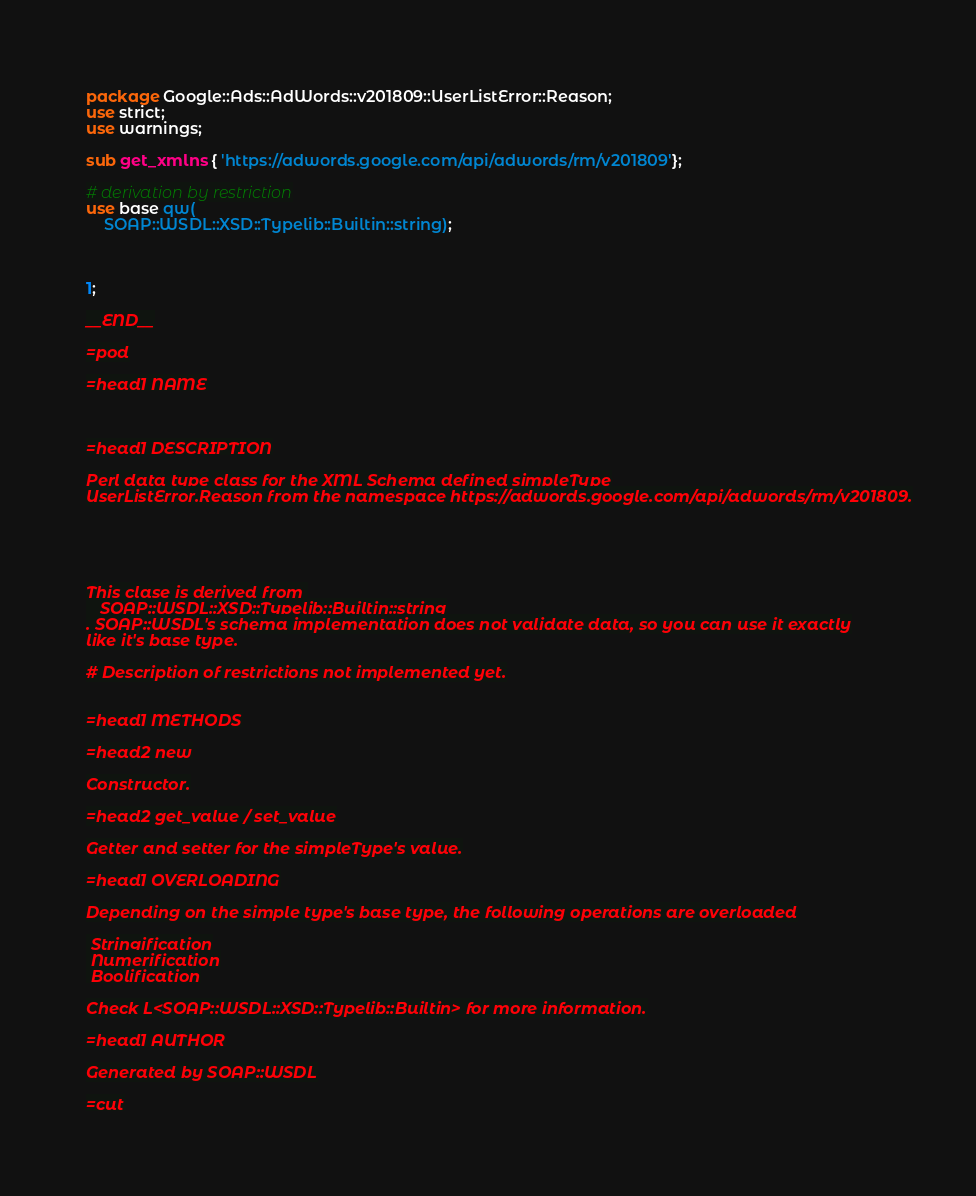Convert code to text. <code><loc_0><loc_0><loc_500><loc_500><_Perl_>package Google::Ads::AdWords::v201809::UserListError::Reason;
use strict;
use warnings;

sub get_xmlns { 'https://adwords.google.com/api/adwords/rm/v201809'};

# derivation by restriction
use base qw(
    SOAP::WSDL::XSD::Typelib::Builtin::string);



1;

__END__

=pod

=head1 NAME



=head1 DESCRIPTION

Perl data type class for the XML Schema defined simpleType
UserListError.Reason from the namespace https://adwords.google.com/api/adwords/rm/v201809.





This clase is derived from 
   SOAP::WSDL::XSD::Typelib::Builtin::string
. SOAP::WSDL's schema implementation does not validate data, so you can use it exactly
like it's base type.

# Description of restrictions not implemented yet.


=head1 METHODS

=head2 new

Constructor.

=head2 get_value / set_value

Getter and setter for the simpleType's value.

=head1 OVERLOADING

Depending on the simple type's base type, the following operations are overloaded

 Stringification
 Numerification
 Boolification

Check L<SOAP::WSDL::XSD::Typelib::Builtin> for more information.

=head1 AUTHOR

Generated by SOAP::WSDL

=cut

</code> 